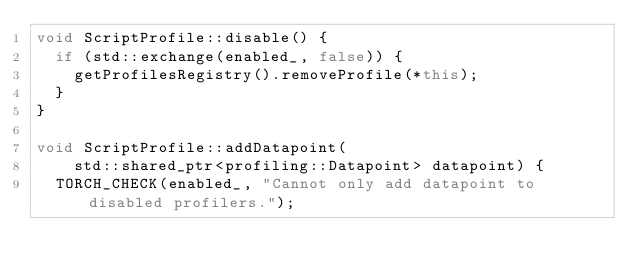<code> <loc_0><loc_0><loc_500><loc_500><_C++_>void ScriptProfile::disable() {
  if (std::exchange(enabled_, false)) {
    getProfilesRegistry().removeProfile(*this);
  }
}

void ScriptProfile::addDatapoint(
    std::shared_ptr<profiling::Datapoint> datapoint) {
  TORCH_CHECK(enabled_, "Cannot only add datapoint to disabled profilers.");</code> 